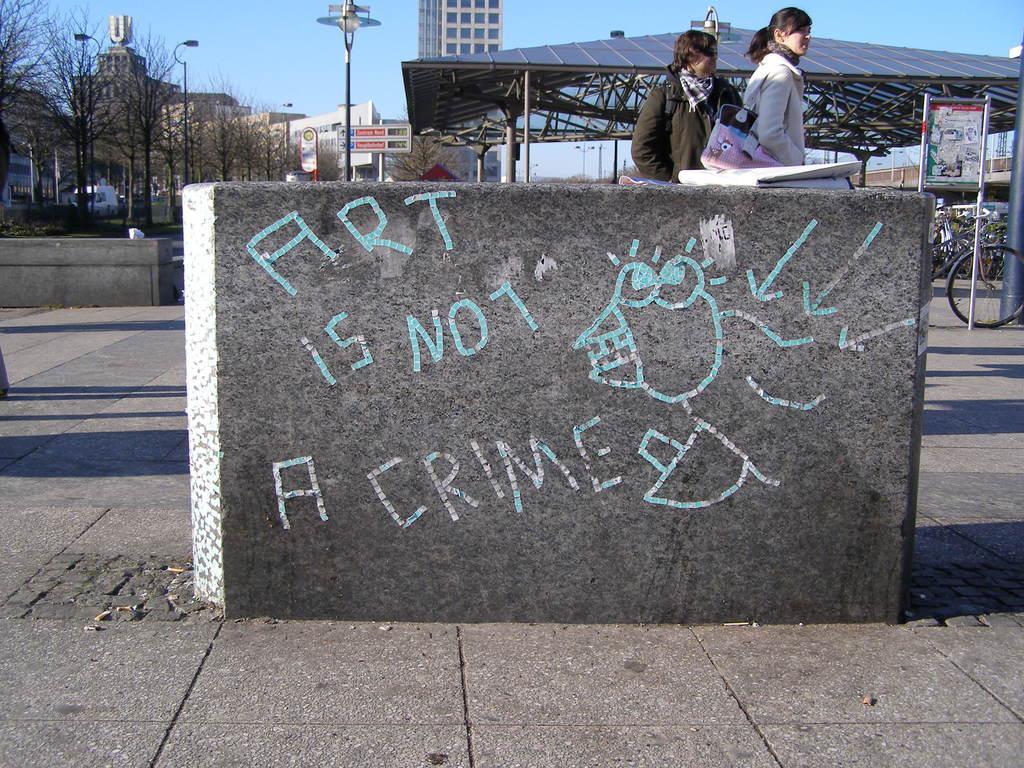In one or two sentences, can you explain what this image depicts? Here in this picture in the middle we can see a big stone present on the ground over there and we can see something written on it and beside that we can see two women standing over there and in the far we can see bicycles all over there under a shed and we can see light posts here and there and we can see buildings present all over there and we can see trees and plants present over 